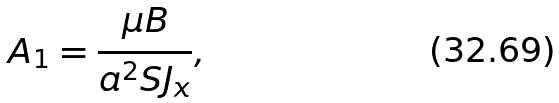<formula> <loc_0><loc_0><loc_500><loc_500>A _ { 1 } = \frac { \mu B } { a ^ { 2 } S J _ { x } } ,</formula> 